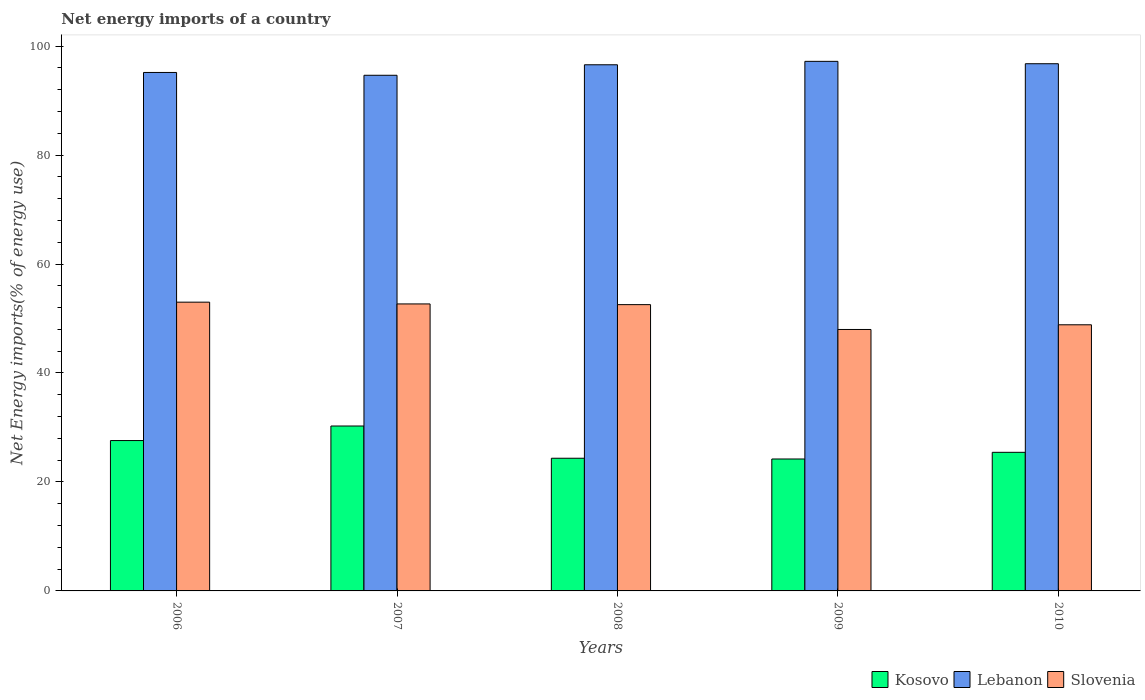How many different coloured bars are there?
Your answer should be compact. 3. Are the number of bars per tick equal to the number of legend labels?
Ensure brevity in your answer.  Yes. How many bars are there on the 5th tick from the left?
Give a very brief answer. 3. How many bars are there on the 4th tick from the right?
Your response must be concise. 3. What is the net energy imports in Lebanon in 2010?
Keep it short and to the point. 96.76. Across all years, what is the maximum net energy imports in Kosovo?
Your answer should be compact. 30.27. Across all years, what is the minimum net energy imports in Lebanon?
Offer a terse response. 94.64. In which year was the net energy imports in Lebanon maximum?
Provide a short and direct response. 2009. What is the total net energy imports in Kosovo in the graph?
Offer a very short reply. 131.86. What is the difference between the net energy imports in Kosovo in 2006 and that in 2008?
Your answer should be very brief. 3.25. What is the difference between the net energy imports in Lebanon in 2010 and the net energy imports in Slovenia in 2009?
Your response must be concise. 48.77. What is the average net energy imports in Slovenia per year?
Offer a terse response. 51.01. In the year 2007, what is the difference between the net energy imports in Slovenia and net energy imports in Lebanon?
Provide a succinct answer. -41.97. In how many years, is the net energy imports in Kosovo greater than 84 %?
Provide a succinct answer. 0. What is the ratio of the net energy imports in Kosovo in 2008 to that in 2010?
Provide a short and direct response. 0.96. What is the difference between the highest and the second highest net energy imports in Lebanon?
Keep it short and to the point. 0.44. What is the difference between the highest and the lowest net energy imports in Slovenia?
Your answer should be very brief. 5.01. In how many years, is the net energy imports in Kosovo greater than the average net energy imports in Kosovo taken over all years?
Offer a terse response. 2. What does the 3rd bar from the left in 2008 represents?
Your response must be concise. Slovenia. What does the 3rd bar from the right in 2009 represents?
Your answer should be very brief. Kosovo. How many bars are there?
Ensure brevity in your answer.  15. What is the difference between two consecutive major ticks on the Y-axis?
Ensure brevity in your answer.  20. Are the values on the major ticks of Y-axis written in scientific E-notation?
Provide a short and direct response. No. Does the graph contain any zero values?
Your response must be concise. No. Does the graph contain grids?
Offer a terse response. No. Where does the legend appear in the graph?
Your answer should be very brief. Bottom right. How many legend labels are there?
Provide a short and direct response. 3. How are the legend labels stacked?
Ensure brevity in your answer.  Horizontal. What is the title of the graph?
Your response must be concise. Net energy imports of a country. What is the label or title of the Y-axis?
Give a very brief answer. Net Energy imports(% of energy use). What is the Net Energy imports(% of energy use) of Kosovo in 2006?
Make the answer very short. 27.6. What is the Net Energy imports(% of energy use) of Lebanon in 2006?
Offer a terse response. 95.15. What is the Net Energy imports(% of energy use) in Slovenia in 2006?
Provide a short and direct response. 53. What is the Net Energy imports(% of energy use) of Kosovo in 2007?
Provide a short and direct response. 30.27. What is the Net Energy imports(% of energy use) in Lebanon in 2007?
Provide a short and direct response. 94.64. What is the Net Energy imports(% of energy use) of Slovenia in 2007?
Give a very brief answer. 52.67. What is the Net Energy imports(% of energy use) in Kosovo in 2008?
Ensure brevity in your answer.  24.35. What is the Net Energy imports(% of energy use) of Lebanon in 2008?
Your answer should be very brief. 96.56. What is the Net Energy imports(% of energy use) in Slovenia in 2008?
Give a very brief answer. 52.54. What is the Net Energy imports(% of energy use) of Kosovo in 2009?
Your response must be concise. 24.21. What is the Net Energy imports(% of energy use) of Lebanon in 2009?
Your answer should be compact. 97.19. What is the Net Energy imports(% of energy use) of Slovenia in 2009?
Make the answer very short. 47.98. What is the Net Energy imports(% of energy use) of Kosovo in 2010?
Make the answer very short. 25.44. What is the Net Energy imports(% of energy use) in Lebanon in 2010?
Give a very brief answer. 96.76. What is the Net Energy imports(% of energy use) of Slovenia in 2010?
Your response must be concise. 48.84. Across all years, what is the maximum Net Energy imports(% of energy use) of Kosovo?
Ensure brevity in your answer.  30.27. Across all years, what is the maximum Net Energy imports(% of energy use) of Lebanon?
Offer a terse response. 97.19. Across all years, what is the maximum Net Energy imports(% of energy use) in Slovenia?
Provide a succinct answer. 53. Across all years, what is the minimum Net Energy imports(% of energy use) in Kosovo?
Provide a short and direct response. 24.21. Across all years, what is the minimum Net Energy imports(% of energy use) in Lebanon?
Offer a very short reply. 94.64. Across all years, what is the minimum Net Energy imports(% of energy use) in Slovenia?
Offer a very short reply. 47.98. What is the total Net Energy imports(% of energy use) of Kosovo in the graph?
Provide a succinct answer. 131.86. What is the total Net Energy imports(% of energy use) of Lebanon in the graph?
Keep it short and to the point. 480.31. What is the total Net Energy imports(% of energy use) of Slovenia in the graph?
Your response must be concise. 255.04. What is the difference between the Net Energy imports(% of energy use) in Kosovo in 2006 and that in 2007?
Offer a very short reply. -2.67. What is the difference between the Net Energy imports(% of energy use) of Lebanon in 2006 and that in 2007?
Your answer should be very brief. 0.52. What is the difference between the Net Energy imports(% of energy use) of Slovenia in 2006 and that in 2007?
Your answer should be compact. 0.32. What is the difference between the Net Energy imports(% of energy use) in Kosovo in 2006 and that in 2008?
Your answer should be very brief. 3.25. What is the difference between the Net Energy imports(% of energy use) of Lebanon in 2006 and that in 2008?
Your answer should be compact. -1.41. What is the difference between the Net Energy imports(% of energy use) in Slovenia in 2006 and that in 2008?
Your response must be concise. 0.45. What is the difference between the Net Energy imports(% of energy use) in Kosovo in 2006 and that in 2009?
Your response must be concise. 3.38. What is the difference between the Net Energy imports(% of energy use) in Lebanon in 2006 and that in 2009?
Your answer should be very brief. -2.04. What is the difference between the Net Energy imports(% of energy use) of Slovenia in 2006 and that in 2009?
Offer a terse response. 5.01. What is the difference between the Net Energy imports(% of energy use) of Kosovo in 2006 and that in 2010?
Ensure brevity in your answer.  2.16. What is the difference between the Net Energy imports(% of energy use) in Lebanon in 2006 and that in 2010?
Provide a short and direct response. -1.6. What is the difference between the Net Energy imports(% of energy use) of Slovenia in 2006 and that in 2010?
Your response must be concise. 4.15. What is the difference between the Net Energy imports(% of energy use) of Kosovo in 2007 and that in 2008?
Give a very brief answer. 5.91. What is the difference between the Net Energy imports(% of energy use) in Lebanon in 2007 and that in 2008?
Make the answer very short. -1.93. What is the difference between the Net Energy imports(% of energy use) in Slovenia in 2007 and that in 2008?
Your answer should be compact. 0.13. What is the difference between the Net Energy imports(% of energy use) in Kosovo in 2007 and that in 2009?
Your response must be concise. 6.05. What is the difference between the Net Energy imports(% of energy use) in Lebanon in 2007 and that in 2009?
Give a very brief answer. -2.55. What is the difference between the Net Energy imports(% of energy use) of Slovenia in 2007 and that in 2009?
Give a very brief answer. 4.69. What is the difference between the Net Energy imports(% of energy use) of Kosovo in 2007 and that in 2010?
Provide a succinct answer. 4.83. What is the difference between the Net Energy imports(% of energy use) in Lebanon in 2007 and that in 2010?
Your answer should be compact. -2.12. What is the difference between the Net Energy imports(% of energy use) in Slovenia in 2007 and that in 2010?
Give a very brief answer. 3.83. What is the difference between the Net Energy imports(% of energy use) in Kosovo in 2008 and that in 2009?
Provide a short and direct response. 0.14. What is the difference between the Net Energy imports(% of energy use) in Lebanon in 2008 and that in 2009?
Offer a terse response. -0.63. What is the difference between the Net Energy imports(% of energy use) in Slovenia in 2008 and that in 2009?
Provide a succinct answer. 4.56. What is the difference between the Net Energy imports(% of energy use) in Kosovo in 2008 and that in 2010?
Offer a very short reply. -1.09. What is the difference between the Net Energy imports(% of energy use) of Lebanon in 2008 and that in 2010?
Your answer should be compact. -0.19. What is the difference between the Net Energy imports(% of energy use) of Slovenia in 2008 and that in 2010?
Ensure brevity in your answer.  3.7. What is the difference between the Net Energy imports(% of energy use) of Kosovo in 2009 and that in 2010?
Give a very brief answer. -1.22. What is the difference between the Net Energy imports(% of energy use) in Lebanon in 2009 and that in 2010?
Offer a terse response. 0.44. What is the difference between the Net Energy imports(% of energy use) of Slovenia in 2009 and that in 2010?
Offer a very short reply. -0.86. What is the difference between the Net Energy imports(% of energy use) of Kosovo in 2006 and the Net Energy imports(% of energy use) of Lebanon in 2007?
Provide a short and direct response. -67.04. What is the difference between the Net Energy imports(% of energy use) of Kosovo in 2006 and the Net Energy imports(% of energy use) of Slovenia in 2007?
Ensure brevity in your answer.  -25.08. What is the difference between the Net Energy imports(% of energy use) of Lebanon in 2006 and the Net Energy imports(% of energy use) of Slovenia in 2007?
Offer a terse response. 42.48. What is the difference between the Net Energy imports(% of energy use) of Kosovo in 2006 and the Net Energy imports(% of energy use) of Lebanon in 2008?
Your response must be concise. -68.97. What is the difference between the Net Energy imports(% of energy use) of Kosovo in 2006 and the Net Energy imports(% of energy use) of Slovenia in 2008?
Offer a terse response. -24.95. What is the difference between the Net Energy imports(% of energy use) in Lebanon in 2006 and the Net Energy imports(% of energy use) in Slovenia in 2008?
Give a very brief answer. 42.61. What is the difference between the Net Energy imports(% of energy use) of Kosovo in 2006 and the Net Energy imports(% of energy use) of Lebanon in 2009?
Your response must be concise. -69.6. What is the difference between the Net Energy imports(% of energy use) in Kosovo in 2006 and the Net Energy imports(% of energy use) in Slovenia in 2009?
Offer a terse response. -20.39. What is the difference between the Net Energy imports(% of energy use) of Lebanon in 2006 and the Net Energy imports(% of energy use) of Slovenia in 2009?
Offer a terse response. 47.17. What is the difference between the Net Energy imports(% of energy use) of Kosovo in 2006 and the Net Energy imports(% of energy use) of Lebanon in 2010?
Provide a succinct answer. -69.16. What is the difference between the Net Energy imports(% of energy use) of Kosovo in 2006 and the Net Energy imports(% of energy use) of Slovenia in 2010?
Your answer should be very brief. -21.25. What is the difference between the Net Energy imports(% of energy use) in Lebanon in 2006 and the Net Energy imports(% of energy use) in Slovenia in 2010?
Offer a terse response. 46.31. What is the difference between the Net Energy imports(% of energy use) in Kosovo in 2007 and the Net Energy imports(% of energy use) in Lebanon in 2008?
Provide a short and direct response. -66.3. What is the difference between the Net Energy imports(% of energy use) of Kosovo in 2007 and the Net Energy imports(% of energy use) of Slovenia in 2008?
Keep it short and to the point. -22.28. What is the difference between the Net Energy imports(% of energy use) in Lebanon in 2007 and the Net Energy imports(% of energy use) in Slovenia in 2008?
Keep it short and to the point. 42.1. What is the difference between the Net Energy imports(% of energy use) in Kosovo in 2007 and the Net Energy imports(% of energy use) in Lebanon in 2009?
Provide a short and direct response. -66.93. What is the difference between the Net Energy imports(% of energy use) in Kosovo in 2007 and the Net Energy imports(% of energy use) in Slovenia in 2009?
Make the answer very short. -17.72. What is the difference between the Net Energy imports(% of energy use) of Lebanon in 2007 and the Net Energy imports(% of energy use) of Slovenia in 2009?
Offer a very short reply. 46.66. What is the difference between the Net Energy imports(% of energy use) of Kosovo in 2007 and the Net Energy imports(% of energy use) of Lebanon in 2010?
Keep it short and to the point. -66.49. What is the difference between the Net Energy imports(% of energy use) of Kosovo in 2007 and the Net Energy imports(% of energy use) of Slovenia in 2010?
Offer a very short reply. -18.58. What is the difference between the Net Energy imports(% of energy use) in Lebanon in 2007 and the Net Energy imports(% of energy use) in Slovenia in 2010?
Provide a short and direct response. 45.79. What is the difference between the Net Energy imports(% of energy use) of Kosovo in 2008 and the Net Energy imports(% of energy use) of Lebanon in 2009?
Your answer should be compact. -72.84. What is the difference between the Net Energy imports(% of energy use) of Kosovo in 2008 and the Net Energy imports(% of energy use) of Slovenia in 2009?
Your response must be concise. -23.63. What is the difference between the Net Energy imports(% of energy use) in Lebanon in 2008 and the Net Energy imports(% of energy use) in Slovenia in 2009?
Make the answer very short. 48.58. What is the difference between the Net Energy imports(% of energy use) in Kosovo in 2008 and the Net Energy imports(% of energy use) in Lebanon in 2010?
Offer a very short reply. -72.41. What is the difference between the Net Energy imports(% of energy use) of Kosovo in 2008 and the Net Energy imports(% of energy use) of Slovenia in 2010?
Ensure brevity in your answer.  -24.49. What is the difference between the Net Energy imports(% of energy use) in Lebanon in 2008 and the Net Energy imports(% of energy use) in Slovenia in 2010?
Ensure brevity in your answer.  47.72. What is the difference between the Net Energy imports(% of energy use) of Kosovo in 2009 and the Net Energy imports(% of energy use) of Lebanon in 2010?
Ensure brevity in your answer.  -72.54. What is the difference between the Net Energy imports(% of energy use) in Kosovo in 2009 and the Net Energy imports(% of energy use) in Slovenia in 2010?
Provide a succinct answer. -24.63. What is the difference between the Net Energy imports(% of energy use) of Lebanon in 2009 and the Net Energy imports(% of energy use) of Slovenia in 2010?
Offer a very short reply. 48.35. What is the average Net Energy imports(% of energy use) in Kosovo per year?
Provide a succinct answer. 26.37. What is the average Net Energy imports(% of energy use) in Lebanon per year?
Give a very brief answer. 96.06. What is the average Net Energy imports(% of energy use) of Slovenia per year?
Give a very brief answer. 51.01. In the year 2006, what is the difference between the Net Energy imports(% of energy use) in Kosovo and Net Energy imports(% of energy use) in Lebanon?
Offer a very short reply. -67.56. In the year 2006, what is the difference between the Net Energy imports(% of energy use) of Kosovo and Net Energy imports(% of energy use) of Slovenia?
Make the answer very short. -25.4. In the year 2006, what is the difference between the Net Energy imports(% of energy use) of Lebanon and Net Energy imports(% of energy use) of Slovenia?
Keep it short and to the point. 42.16. In the year 2007, what is the difference between the Net Energy imports(% of energy use) of Kosovo and Net Energy imports(% of energy use) of Lebanon?
Your answer should be compact. -64.37. In the year 2007, what is the difference between the Net Energy imports(% of energy use) in Kosovo and Net Energy imports(% of energy use) in Slovenia?
Provide a succinct answer. -22.41. In the year 2007, what is the difference between the Net Energy imports(% of energy use) of Lebanon and Net Energy imports(% of energy use) of Slovenia?
Offer a very short reply. 41.97. In the year 2008, what is the difference between the Net Energy imports(% of energy use) in Kosovo and Net Energy imports(% of energy use) in Lebanon?
Give a very brief answer. -72.21. In the year 2008, what is the difference between the Net Energy imports(% of energy use) in Kosovo and Net Energy imports(% of energy use) in Slovenia?
Make the answer very short. -28.19. In the year 2008, what is the difference between the Net Energy imports(% of energy use) of Lebanon and Net Energy imports(% of energy use) of Slovenia?
Your response must be concise. 44.02. In the year 2009, what is the difference between the Net Energy imports(% of energy use) of Kosovo and Net Energy imports(% of energy use) of Lebanon?
Offer a very short reply. -72.98. In the year 2009, what is the difference between the Net Energy imports(% of energy use) of Kosovo and Net Energy imports(% of energy use) of Slovenia?
Your answer should be very brief. -23.77. In the year 2009, what is the difference between the Net Energy imports(% of energy use) in Lebanon and Net Energy imports(% of energy use) in Slovenia?
Your answer should be compact. 49.21. In the year 2010, what is the difference between the Net Energy imports(% of energy use) of Kosovo and Net Energy imports(% of energy use) of Lebanon?
Make the answer very short. -71.32. In the year 2010, what is the difference between the Net Energy imports(% of energy use) in Kosovo and Net Energy imports(% of energy use) in Slovenia?
Your answer should be very brief. -23.41. In the year 2010, what is the difference between the Net Energy imports(% of energy use) of Lebanon and Net Energy imports(% of energy use) of Slovenia?
Make the answer very short. 47.91. What is the ratio of the Net Energy imports(% of energy use) in Kosovo in 2006 to that in 2007?
Make the answer very short. 0.91. What is the ratio of the Net Energy imports(% of energy use) of Lebanon in 2006 to that in 2007?
Keep it short and to the point. 1.01. What is the ratio of the Net Energy imports(% of energy use) in Slovenia in 2006 to that in 2007?
Offer a very short reply. 1.01. What is the ratio of the Net Energy imports(% of energy use) in Kosovo in 2006 to that in 2008?
Offer a terse response. 1.13. What is the ratio of the Net Energy imports(% of energy use) of Lebanon in 2006 to that in 2008?
Provide a short and direct response. 0.99. What is the ratio of the Net Energy imports(% of energy use) of Slovenia in 2006 to that in 2008?
Your answer should be very brief. 1.01. What is the ratio of the Net Energy imports(% of energy use) of Kosovo in 2006 to that in 2009?
Offer a terse response. 1.14. What is the ratio of the Net Energy imports(% of energy use) of Lebanon in 2006 to that in 2009?
Provide a short and direct response. 0.98. What is the ratio of the Net Energy imports(% of energy use) in Slovenia in 2006 to that in 2009?
Provide a succinct answer. 1.1. What is the ratio of the Net Energy imports(% of energy use) of Kosovo in 2006 to that in 2010?
Ensure brevity in your answer.  1.08. What is the ratio of the Net Energy imports(% of energy use) of Lebanon in 2006 to that in 2010?
Make the answer very short. 0.98. What is the ratio of the Net Energy imports(% of energy use) of Slovenia in 2006 to that in 2010?
Your response must be concise. 1.08. What is the ratio of the Net Energy imports(% of energy use) in Kosovo in 2007 to that in 2008?
Provide a short and direct response. 1.24. What is the ratio of the Net Energy imports(% of energy use) in Lebanon in 2007 to that in 2008?
Provide a succinct answer. 0.98. What is the ratio of the Net Energy imports(% of energy use) of Kosovo in 2007 to that in 2009?
Provide a short and direct response. 1.25. What is the ratio of the Net Energy imports(% of energy use) of Lebanon in 2007 to that in 2009?
Give a very brief answer. 0.97. What is the ratio of the Net Energy imports(% of energy use) of Slovenia in 2007 to that in 2009?
Provide a succinct answer. 1.1. What is the ratio of the Net Energy imports(% of energy use) of Kosovo in 2007 to that in 2010?
Make the answer very short. 1.19. What is the ratio of the Net Energy imports(% of energy use) of Lebanon in 2007 to that in 2010?
Give a very brief answer. 0.98. What is the ratio of the Net Energy imports(% of energy use) of Slovenia in 2007 to that in 2010?
Provide a short and direct response. 1.08. What is the ratio of the Net Energy imports(% of energy use) in Kosovo in 2008 to that in 2009?
Ensure brevity in your answer.  1.01. What is the ratio of the Net Energy imports(% of energy use) of Lebanon in 2008 to that in 2009?
Make the answer very short. 0.99. What is the ratio of the Net Energy imports(% of energy use) of Slovenia in 2008 to that in 2009?
Your answer should be compact. 1.09. What is the ratio of the Net Energy imports(% of energy use) of Kosovo in 2008 to that in 2010?
Keep it short and to the point. 0.96. What is the ratio of the Net Energy imports(% of energy use) of Slovenia in 2008 to that in 2010?
Give a very brief answer. 1.08. What is the ratio of the Net Energy imports(% of energy use) of Kosovo in 2009 to that in 2010?
Your response must be concise. 0.95. What is the ratio of the Net Energy imports(% of energy use) in Slovenia in 2009 to that in 2010?
Keep it short and to the point. 0.98. What is the difference between the highest and the second highest Net Energy imports(% of energy use) of Kosovo?
Offer a very short reply. 2.67. What is the difference between the highest and the second highest Net Energy imports(% of energy use) of Lebanon?
Make the answer very short. 0.44. What is the difference between the highest and the second highest Net Energy imports(% of energy use) in Slovenia?
Ensure brevity in your answer.  0.32. What is the difference between the highest and the lowest Net Energy imports(% of energy use) in Kosovo?
Make the answer very short. 6.05. What is the difference between the highest and the lowest Net Energy imports(% of energy use) in Lebanon?
Your answer should be compact. 2.55. What is the difference between the highest and the lowest Net Energy imports(% of energy use) of Slovenia?
Offer a terse response. 5.01. 